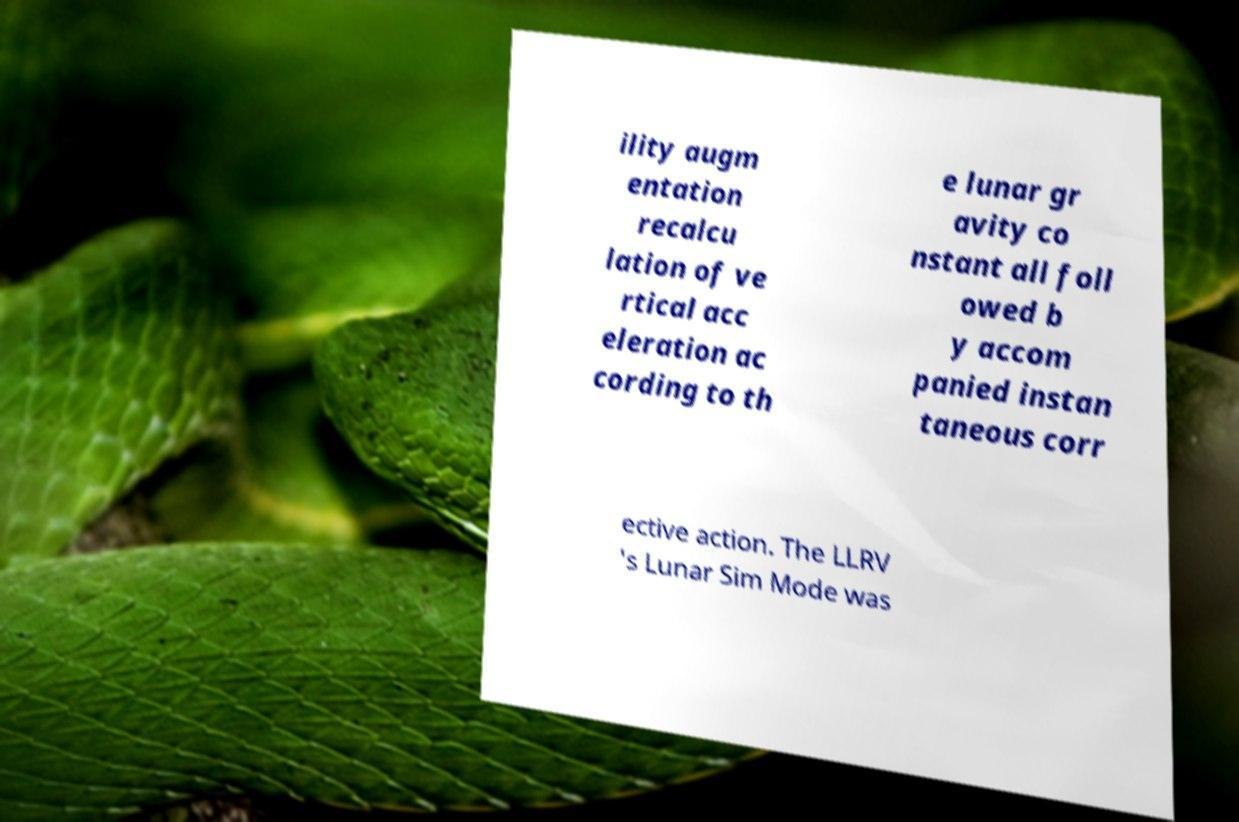I need the written content from this picture converted into text. Can you do that? ility augm entation recalcu lation of ve rtical acc eleration ac cording to th e lunar gr avity co nstant all foll owed b y accom panied instan taneous corr ective action. The LLRV 's Lunar Sim Mode was 